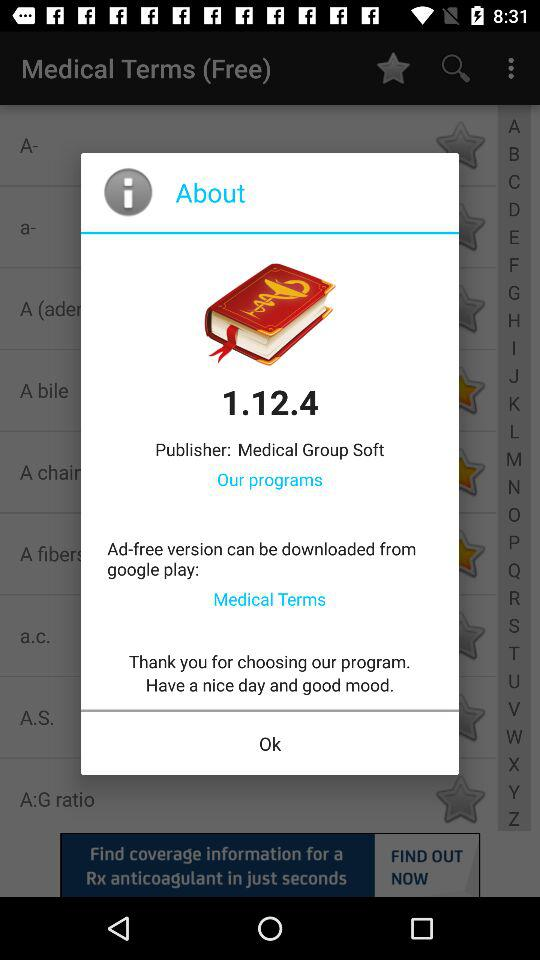Who is the publisher of the application? The publisher of the application is "Medical Group Soft". 